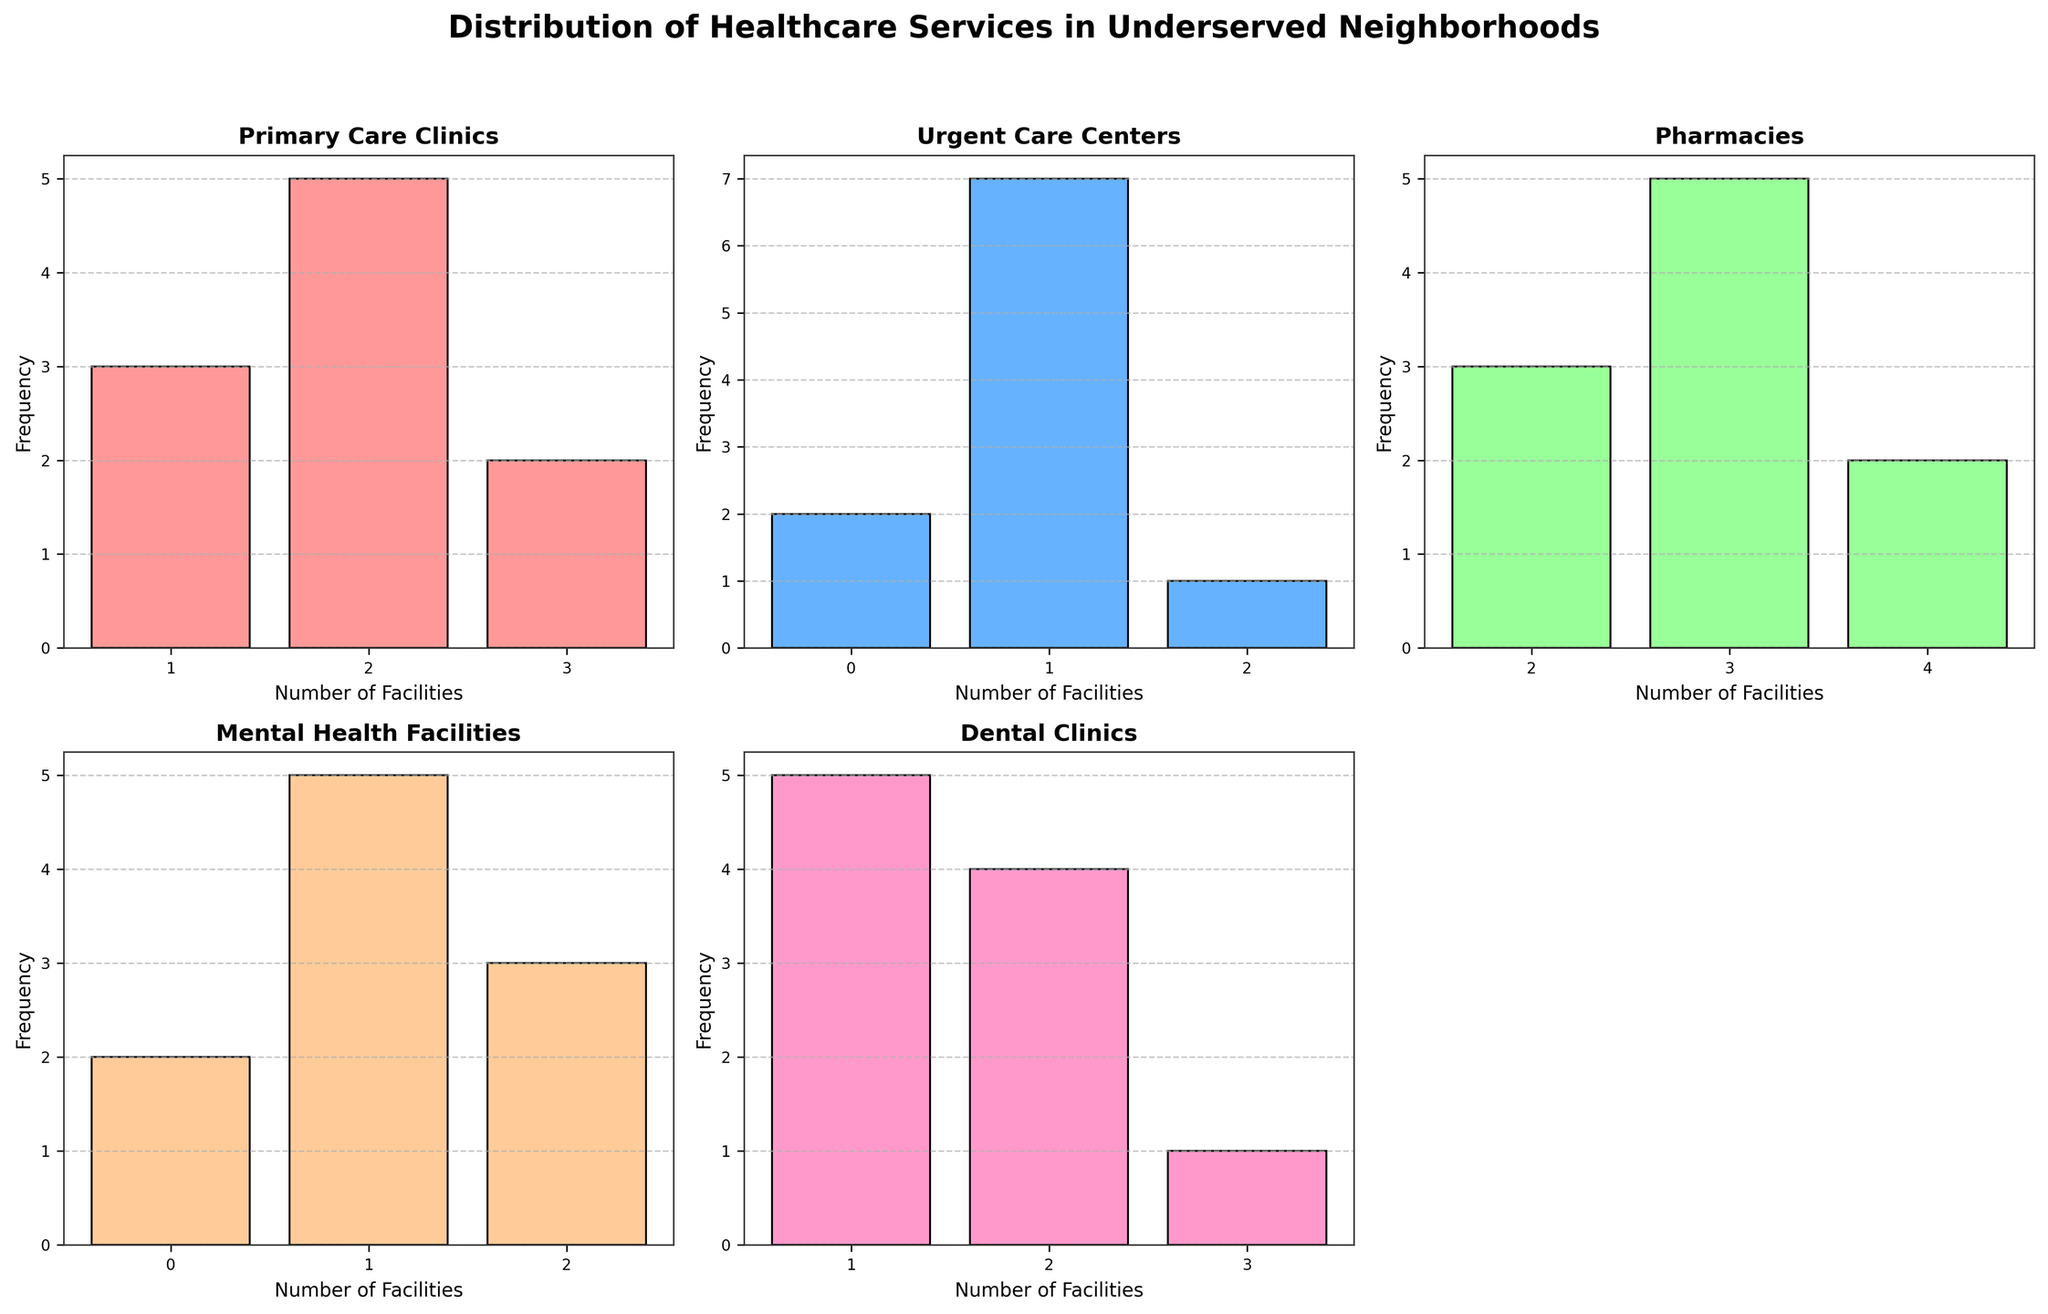What is the title of the figure? The title of the figure is written at the top of the plot in a large, bold font.
Answer: Distribution of Healthcare Services in Underserved Neighborhoods How many subplots are there in the figure? The figure contains individual histograms for each type of healthcare service. Counting these subplots provides the answer.
Answer: 5 Which healthcare service has the highest number of locations in any neighborhood? By examining the x-axis of each subplot, we can find the highest number of locations. The subplot for 'Pharmacies' reveals up to 4 locations.
Answer: Pharmacies How many neighborhoods have 2 Primary Care Clinics? Look at the histogram for Primary Care Clinics and count the number of bins that represent 2 facilities.
Answer: 5 Which type of healthcare service has the most neighborhoods with zero locations? By comparing the histograms, the one with the highest frequency at zero indicates the answer. The 'Urgent Care Centers' histogram shows the highest count of zeros.
Answer: Urgent Care Centers How many neighborhoods have 1 or more Mental Health Facilities? Scan the histogram for Mental Health Facilities and count all bins representing 1 or more facilities.
Answer: 6 Are there more neighborhoods with 4 locations of Pharmacies or 3 locations of Primary Care Clinics? Compare the frequency at 4 locations in the Pharmacies histogram with the frequency at 3 locations in the Primary Care Clinics histogram.
Answer: 4 locations of Pharmacies What is the range of the number of Dental Clinics across all neighborhoods? Identify the minimum and maximum number of Dental Clinics in the corresponding histogram to find the range.
Answer: 0 to 3 Is the number of neighborhoods with 2 Urgent Care Centers greater than those with 2 Dental Clinics? Compare the frequency of the bin representing 2 for Urgent Care Centers to the frequency of the bin representing 2 for Dental Clinics.
Answer: No How many various bins (distinct values) are there in the histogram for Primary Care Clinics? Counting the distinct bins displayed in the histogram for Primary Care Clinics results in the answer.
Answer: 3 